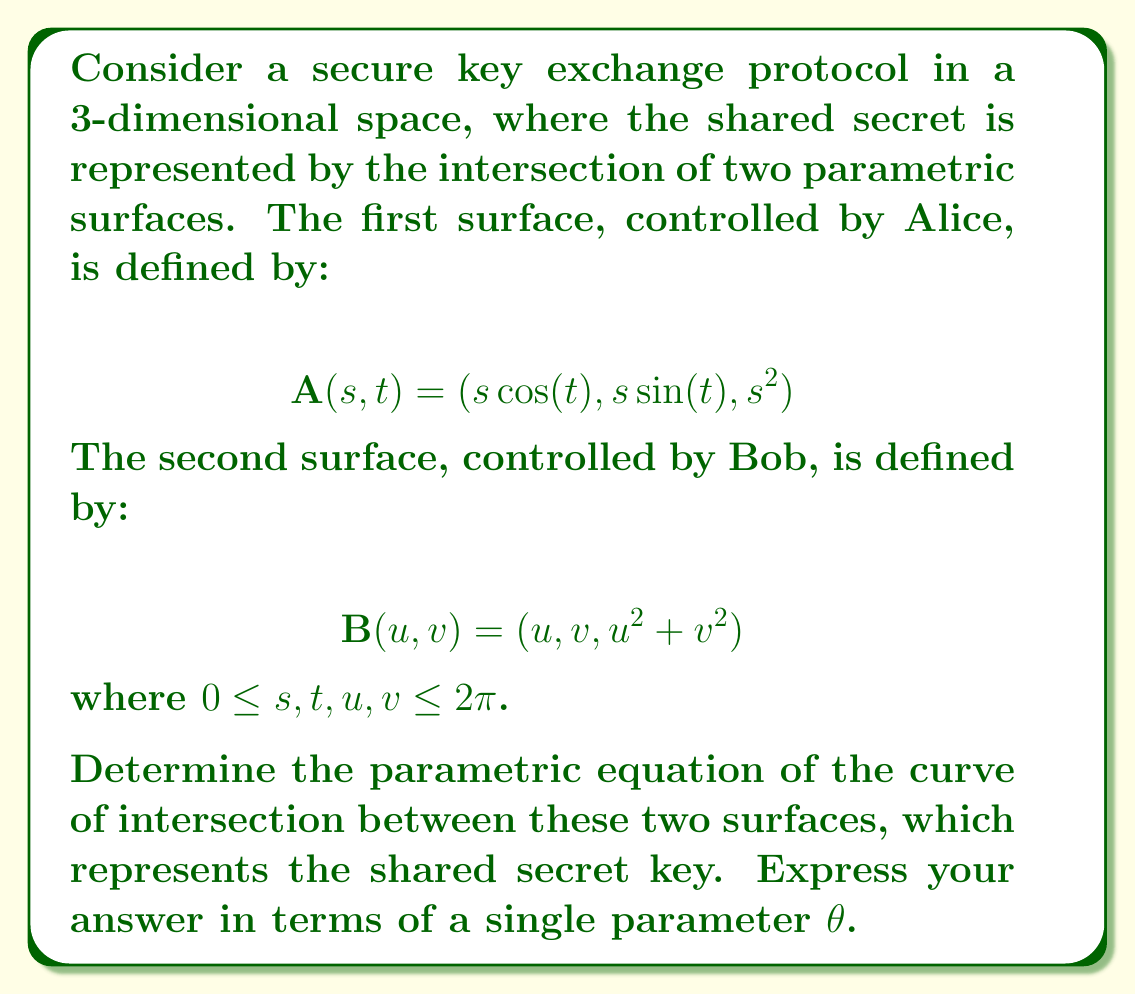Can you answer this question? To find the intersection of the two surfaces, we need to equate their components:

1) First, we equate the x-components:
   $s\cos(t) = u$

2) Next, we equate the y-components:
   $s\sin(t) = v$

3) Finally, we equate the z-components:
   $s^2 = u^2 + v^2$

From steps 1 and 2, we can deduce that $s$ represents the radius in polar coordinates, while $t$ represents the angle. Therefore, we can replace $u$ and $v$ with $s\cos(t)$ and $s\sin(t)$ respectively.

Substituting these into the equation from step 3:

$$s^2 = (s\cos(t))^2 + (s\sin(t))^2$$

This simplifies to:

$$s^2 = s^2(\cos^2(t) + \sin^2(t))$$

$$s^2 = s^2 \cdot 1$$

This equation is true for all values of $s$ and $t$, which means the entire curve of intersection lies on both surfaces.

To express this curve parametrically with a single parameter $\theta$, we can simply substitute $\theta$ for $t$ and use $s = \theta$ (since $s$ can take any value from 0 to $2\pi$):

$$\mathbf{r}(\theta) = (\theta\cos(\theta), \theta\sin(\theta), \theta^2)$$

This parametric equation represents the helical curve of intersection between the two surfaces, which serves as the shared secret key in this 3D key exchange protocol.
Answer: $$\mathbf{r}(\theta) = (\theta\cos(\theta), \theta\sin(\theta), \theta^2)$$
where $0 \leq \theta \leq 2\pi$ 